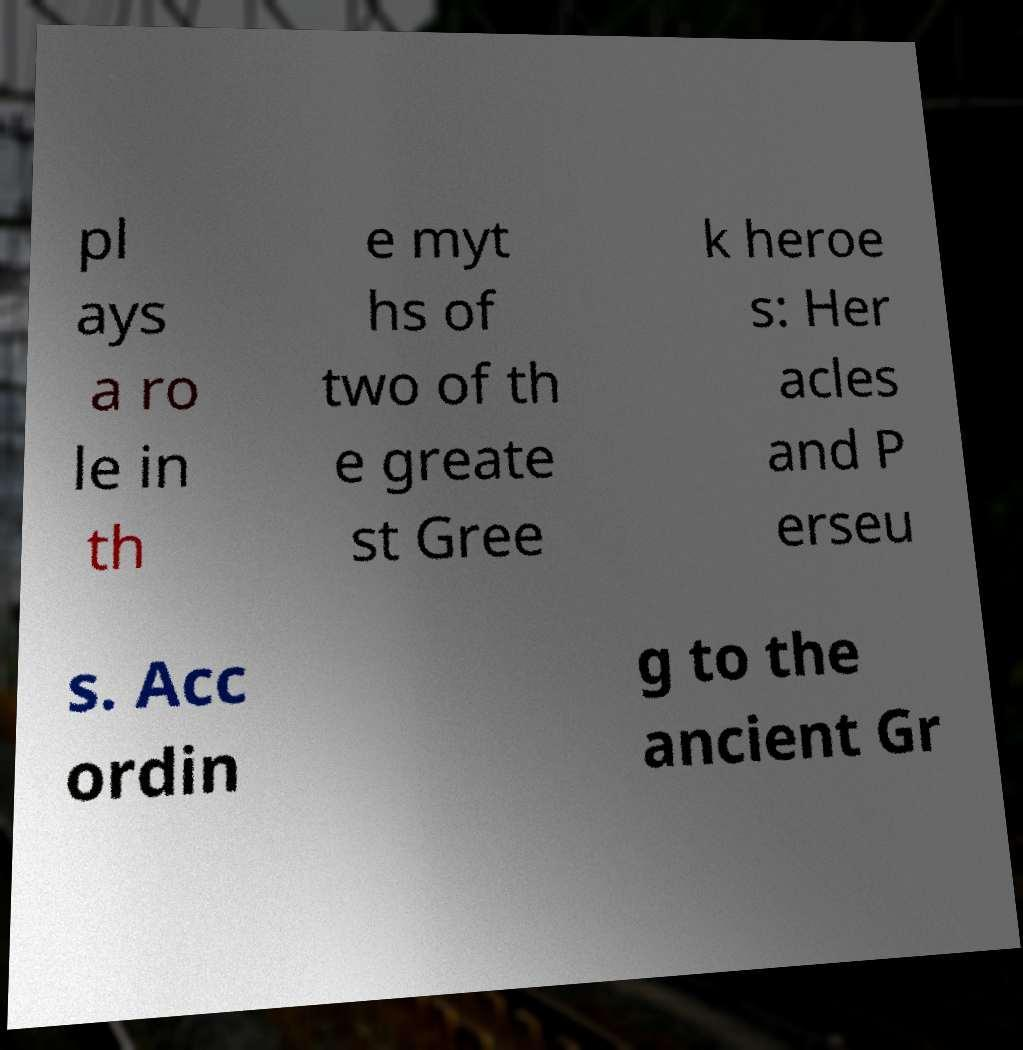I need the written content from this picture converted into text. Can you do that? pl ays a ro le in th e myt hs of two of th e greate st Gree k heroe s: Her acles and P erseu s. Acc ordin g to the ancient Gr 